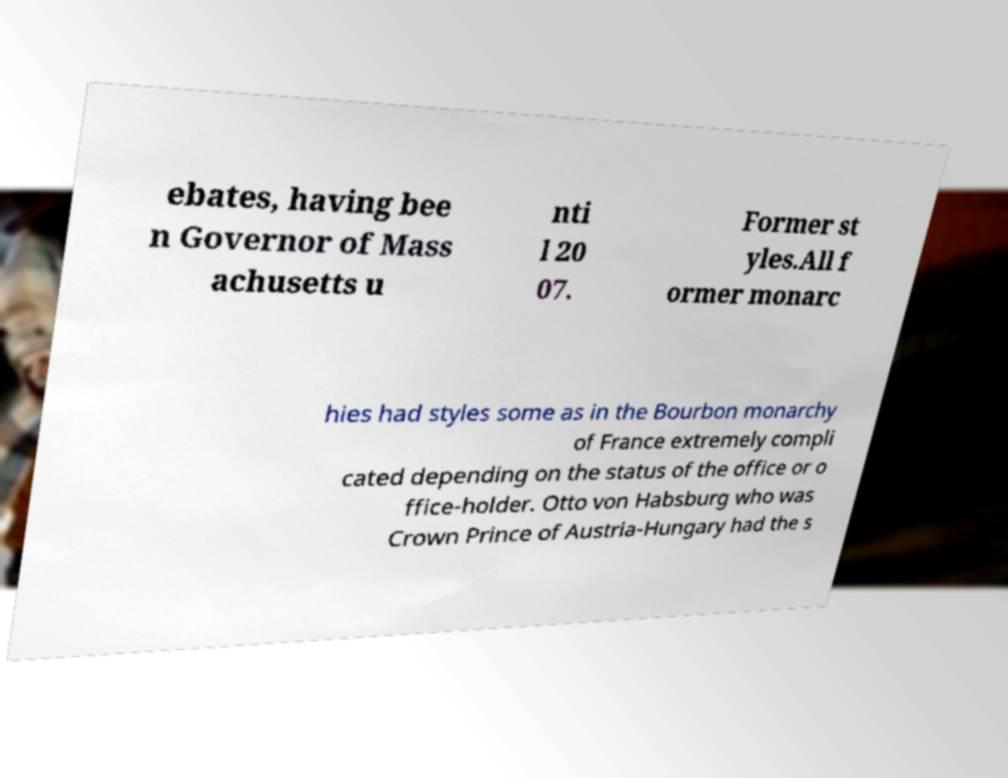Please read and relay the text visible in this image. What does it say? ebates, having bee n Governor of Mass achusetts u nti l 20 07. Former st yles.All f ormer monarc hies had styles some as in the Bourbon monarchy of France extremely compli cated depending on the status of the office or o ffice-holder. Otto von Habsburg who was Crown Prince of Austria-Hungary had the s 